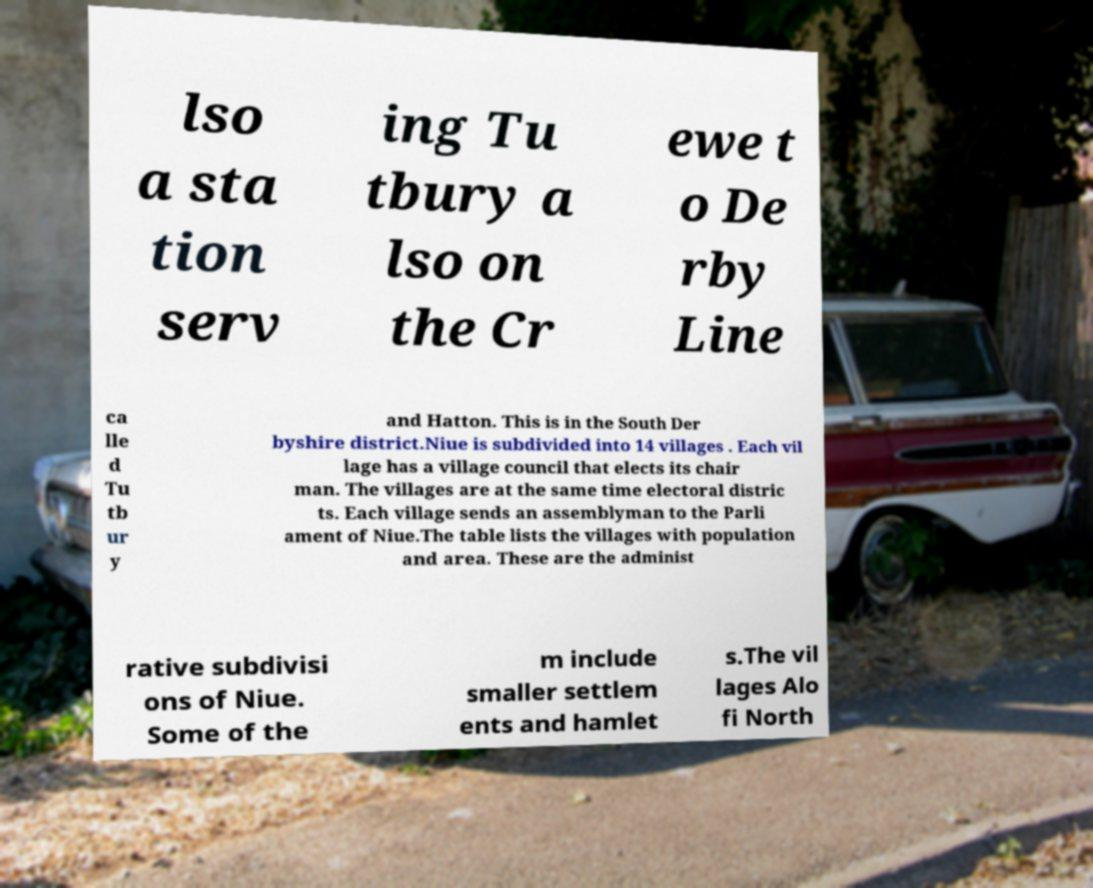Could you extract and type out the text from this image? lso a sta tion serv ing Tu tbury a lso on the Cr ewe t o De rby Line ca lle d Tu tb ur y and Hatton. This is in the South Der byshire district.Niue is subdivided into 14 villages . Each vil lage has a village council that elects its chair man. The villages are at the same time electoral distric ts. Each village sends an assemblyman to the Parli ament of Niue.The table lists the villages with population and area. These are the administ rative subdivisi ons of Niue. Some of the m include smaller settlem ents and hamlet s.The vil lages Alo fi North 